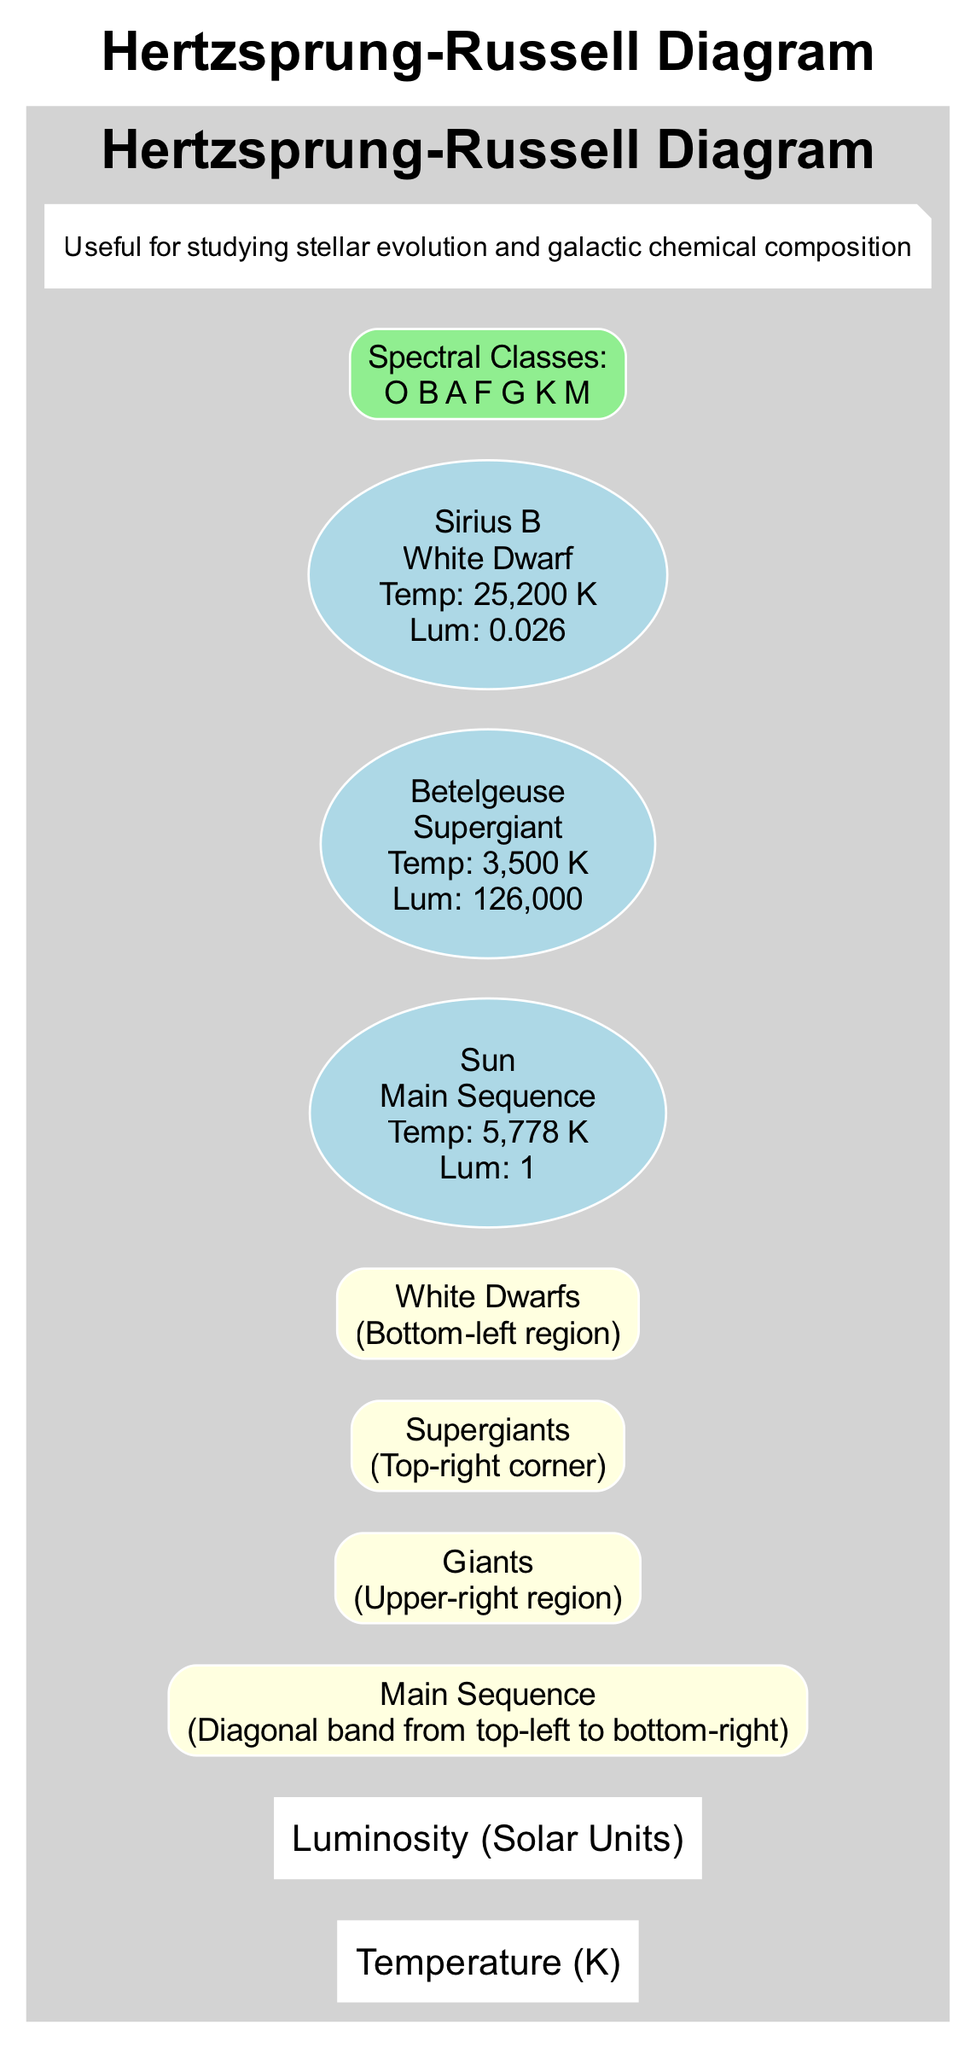What is the temperature of the Sun? The diagram indicates that the Sun has a temperature of 5,778 K, as noted in its description within the Main Sequence area.
Answer: 5,778 K Where are the giants located on the diagram? The giants are positioned in the upper-right region of the diagram, as stated in their description.
Answer: Upper-right region What is the luminosity of Betelgeuse? According to the diagram, Betelgeuse has a luminosity of 126,000 solar units, specified in the Supergiant section.
Answer: 126,000 Which star type has the highest temperature in the diagram? By comparing the example stars, Sirius B, classified as a White Dwarf, has the highest temperature at 25,200 K. This is noted in its description.
Answer: White Dwarf How many major star types are shown in the diagram? The diagram provides four major star types: Main Sequence, Giants, Supergiants, and White Dwarfs. Thus, the total count is four.
Answer: 4 What spectral class is found at the bottom-left region? The bottom-left region corresponds to the White Dwarfs, which can be associated with the cooler end of the spectrum that often includes the M class stars.
Answer: M If a star has a luminosity much higher than the Sun, which region would it likely be found in? A star with a luminosity much higher than the Sun would most likely be found in the Supergiants region, which is located at the top-right corner of the diagram.
Answer: Supergiants What is the temperature range generally displayed along the x-axis? The x-axis represents temperature, starting from lower values on the left (indicating cooler stars) and moving to higher values on the right (indicating hotter stars), thus encompassing a broad range of temperatures.
Answer: Lower to higher temperatures Which star is an example of a White Dwarf? The example star listed as a White Dwarf in the diagram is Sirius B, which also includes critical data about its temperature and luminosity.
Answer: Sirius B 